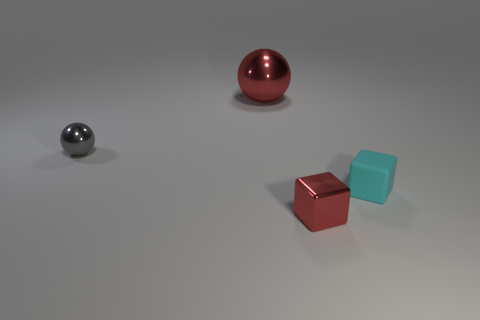Add 1 cyan metallic balls. How many objects exist? 5 Subtract 2 spheres. How many spheres are left? 0 Subtract all green blocks. Subtract all blue cylinders. How many blocks are left? 2 Subtract all red cubes. How many gray spheres are left? 1 Subtract all big red spheres. Subtract all red metallic balls. How many objects are left? 2 Add 1 rubber objects. How many rubber objects are left? 2 Add 1 gray metal balls. How many gray metal balls exist? 2 Subtract 0 cyan cylinders. How many objects are left? 4 